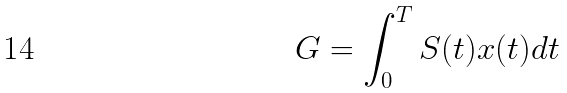<formula> <loc_0><loc_0><loc_500><loc_500>G = \int _ { 0 } ^ { T } S ( t ) x ( t ) d t</formula> 